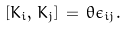Convert formula to latex. <formula><loc_0><loc_0><loc_500><loc_500>[ K _ { i } , \, K _ { j } ] \, = \, \theta \epsilon _ { i j } .</formula> 